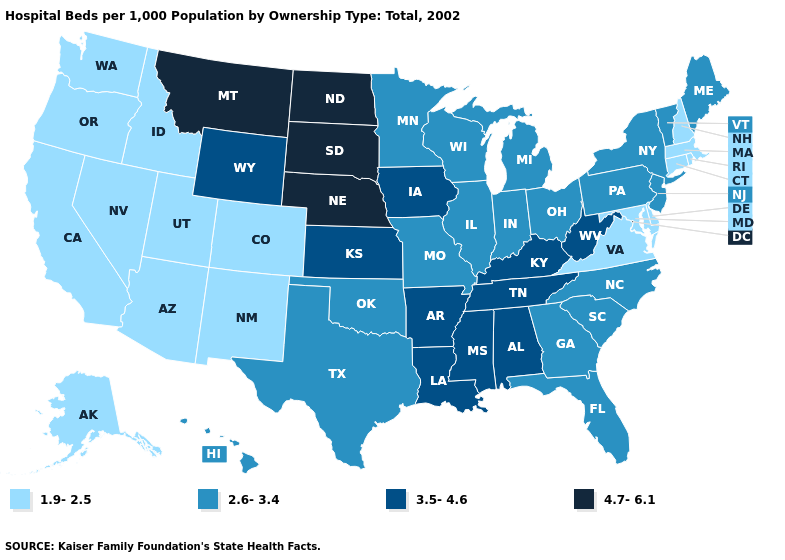Does North Carolina have the same value as Tennessee?
Write a very short answer. No. Name the states that have a value in the range 3.5-4.6?
Quick response, please. Alabama, Arkansas, Iowa, Kansas, Kentucky, Louisiana, Mississippi, Tennessee, West Virginia, Wyoming. Name the states that have a value in the range 3.5-4.6?
Answer briefly. Alabama, Arkansas, Iowa, Kansas, Kentucky, Louisiana, Mississippi, Tennessee, West Virginia, Wyoming. Does the first symbol in the legend represent the smallest category?
Quick response, please. Yes. Among the states that border Utah , does Wyoming have the lowest value?
Keep it brief. No. What is the lowest value in states that border Florida?
Give a very brief answer. 2.6-3.4. Among the states that border Minnesota , does South Dakota have the highest value?
Answer briefly. Yes. Name the states that have a value in the range 3.5-4.6?
Write a very short answer. Alabama, Arkansas, Iowa, Kansas, Kentucky, Louisiana, Mississippi, Tennessee, West Virginia, Wyoming. Among the states that border Nebraska , which have the lowest value?
Write a very short answer. Colorado. What is the value of Arkansas?
Be succinct. 3.5-4.6. Name the states that have a value in the range 2.6-3.4?
Answer briefly. Florida, Georgia, Hawaii, Illinois, Indiana, Maine, Michigan, Minnesota, Missouri, New Jersey, New York, North Carolina, Ohio, Oklahoma, Pennsylvania, South Carolina, Texas, Vermont, Wisconsin. Among the states that border Maryland , which have the lowest value?
Quick response, please. Delaware, Virginia. Does Wisconsin have the lowest value in the USA?
Give a very brief answer. No. What is the value of California?
Be succinct. 1.9-2.5. What is the highest value in the West ?
Be succinct. 4.7-6.1. 